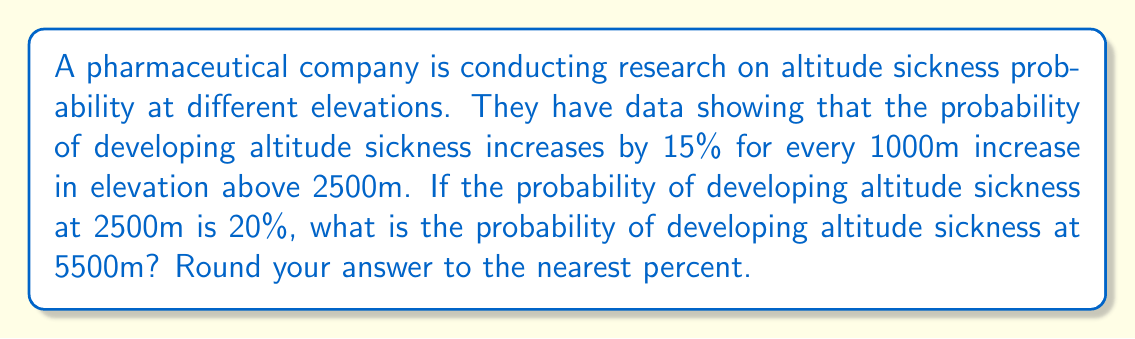Give your solution to this math problem. Let's approach this step-by-step:

1) First, let's identify the key information:
   - Base elevation: 2500m
   - Base probability: 20% or 0.20
   - Increase: 15% or 0.15 per 1000m above 2500m
   - Target elevation: 5500m

2) Calculate the elevation difference:
   $5500m - 2500m = 3000m$

3) Determine how many 1000m intervals this represents:
   $3000m \div 1000m = 3$ intervals

4) Calculate the total increase in probability:
   $0.15 \times 3 = 0.45$ or 45%

5) Add this increase to the base probability:
   $0.20 + 0.45 = 0.65$ or 65%

6) Convert to a percentage and round to the nearest percent:
   $0.65 \times 100\% = 65\%$

Therefore, the probability of developing altitude sickness at 5500m is 65%.
Answer: 65% 